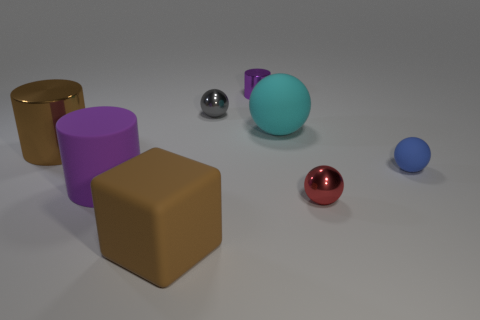Is there any pattern to the arrangement of objects? There does not seem to be a strict pattern, but there is a symmetry in the placement. Objects are paired by shapes across the central line with alternating colors and materials, which might suggest a deliberate, contrasting arrangement. 